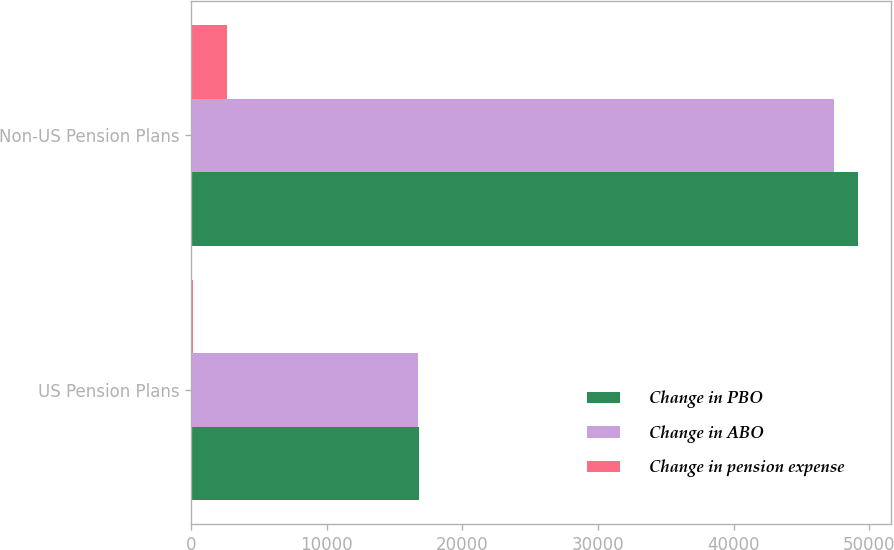Convert chart. <chart><loc_0><loc_0><loc_500><loc_500><stacked_bar_chart><ecel><fcel>US Pension Plans<fcel>Non-US Pension Plans<nl><fcel>Change in PBO<fcel>16777<fcel>49150<nl><fcel>Change in ABO<fcel>16698<fcel>47394<nl><fcel>Change in pension expense<fcel>148<fcel>2677<nl></chart> 